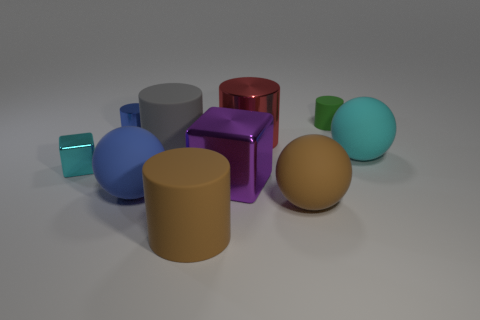Does the big gray thing have the same shape as the red object behind the large blue thing?
Your answer should be very brief. Yes. Is there a cyan thing?
Your answer should be compact. Yes. What number of tiny objects are gray rubber objects or yellow spheres?
Your answer should be very brief. 0. Is the number of purple metal blocks that are on the right side of the large cube greater than the number of green objects on the left side of the big red cylinder?
Keep it short and to the point. No. Is the material of the cyan sphere the same as the cylinder that is in front of the cyan shiny block?
Your response must be concise. Yes. What color is the big metallic cylinder?
Offer a very short reply. Red. There is a shiny thing behind the big red cylinder; what shape is it?
Provide a succinct answer. Cylinder. How many green objects are tiny metallic cylinders or small rubber things?
Your answer should be very brief. 1. What color is the tiny block that is the same material as the big red cylinder?
Provide a short and direct response. Cyan. Do the small cube and the big matte thing that is right of the big brown matte sphere have the same color?
Your answer should be compact. Yes. 